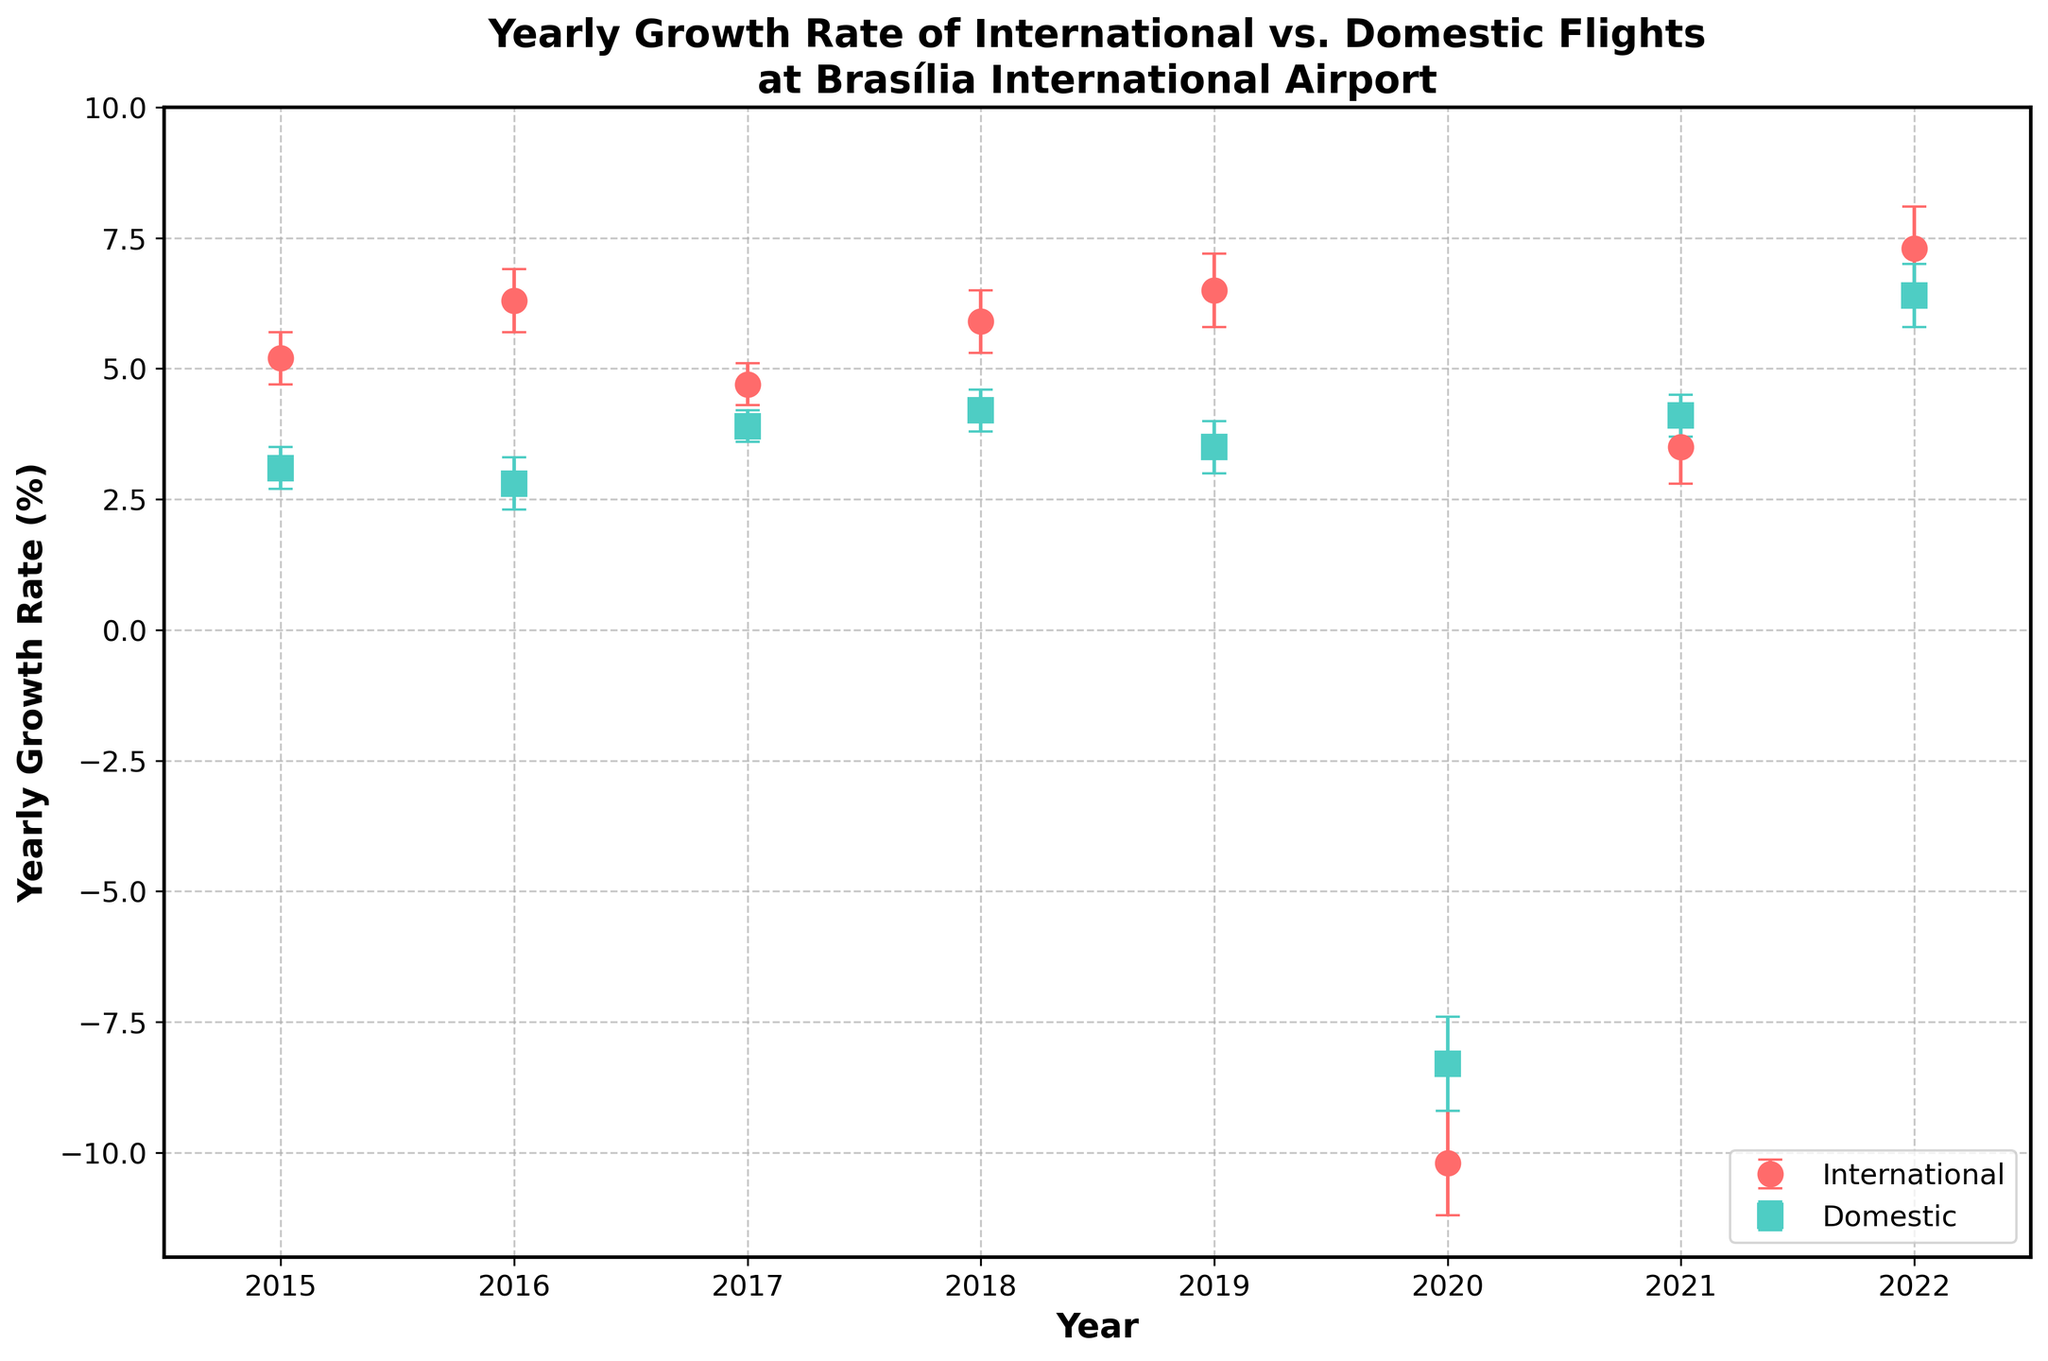What is the title of the plot? The title is typically positioned at the top of the plot, centered for greater visibility. In this case, the title summarizes what the plot is about.
Answer: Yearly Growth Rate of International vs. Domestic Flights at Brasília International Airport What are the two categories compared in the plot? The legend of the plot indicates the two categories, usually with distinctive colors and markers. Here, two categories are shown.
Answer: International and Domestic Which category has the higher yearly growth rate in 2019? To identify this, compare the growth rates for both categories in the year 2019 as shown on the plot.
Answer: International What was the yearly growth rate of domestic flights in 2020? Locate the year 2020 on the x-axis and find the corresponding data point for domestic flights. The value at this point represents the yearly growth rate.
Answer: -8.3% How much did the yearly growth rate for international flights change from 2019 to 2020? Find the data points for international flights in 2019 and 2020. Calculate the difference between these two points.
Answer: 6.5% - (-10.2%) = 16.7% In which year did the domestic flights exhibit their highest yearly growth rate? Look at the data points for domestic flights across all the years and identify the year with the highest value.
Answer: 2022 What is the margin of error for international flights in 2020? From the error bars on the plot, locate the margin of error for international flights in the year 2020. This information is also listed if directly referenced.
Answer: 1.0% How do the margins of error for domestic and international flights in 2022 compare? For the year 2022, compare the error bars or look up the margin of error values for both categories.
Answer: Domestic: 0.6%, International: 0.8% Between which two consecutive years did international flights show the largest decrease in growth rate? Track the changes year by year for international flights and note the largest decrease between consecutive years.
Answer: 2019 to 2020 By how much did the yearly growth rate of domestic flights increase from 2020 to 2021? Locate the data points for domestic flights in 2020 and 2021 and compute the difference between them.
Answer: 4.1% - (-8.3%) = 12.4% 